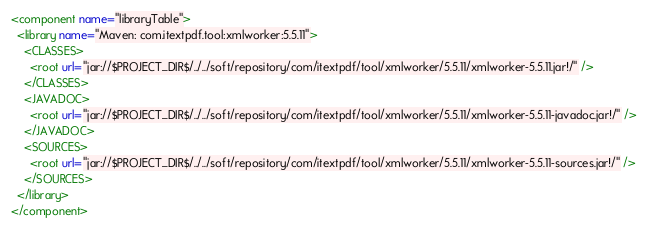Convert code to text. <code><loc_0><loc_0><loc_500><loc_500><_XML_><component name="libraryTable">
  <library name="Maven: com.itextpdf.tool:xmlworker:5.5.11">
    <CLASSES>
      <root url="jar://$PROJECT_DIR$/../../soft/repository/com/itextpdf/tool/xmlworker/5.5.11/xmlworker-5.5.11.jar!/" />
    </CLASSES>
    <JAVADOC>
      <root url="jar://$PROJECT_DIR$/../../soft/repository/com/itextpdf/tool/xmlworker/5.5.11/xmlworker-5.5.11-javadoc.jar!/" />
    </JAVADOC>
    <SOURCES>
      <root url="jar://$PROJECT_DIR$/../../soft/repository/com/itextpdf/tool/xmlworker/5.5.11/xmlworker-5.5.11-sources.jar!/" />
    </SOURCES>
  </library>
</component></code> 